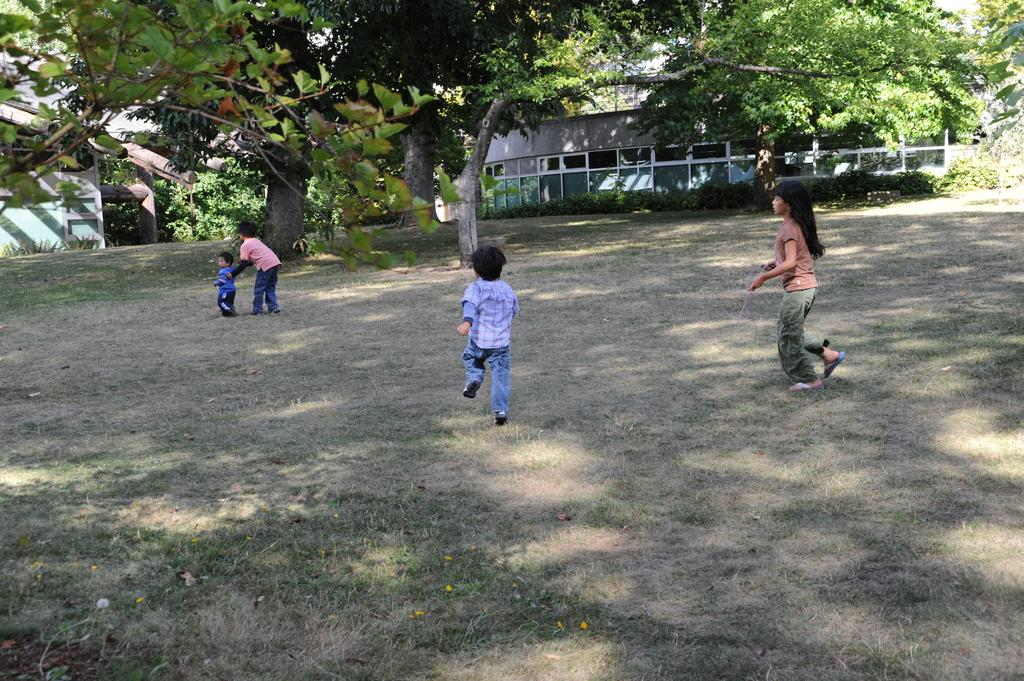What is the main subject of the image? The main subject of the image is the kids in the center of the image. What can be seen in the background of the image? There are buildings and trees in the background of the image. What is visible at the bottom of the image? The ground is visible at the bottom of the image. What type of magic is being performed by the kids in the image? There is no indication of magic or any magical activity in the image; it simply shows kids in the center of the image. What is the quill used for in the image? There is no quill present in the image. 